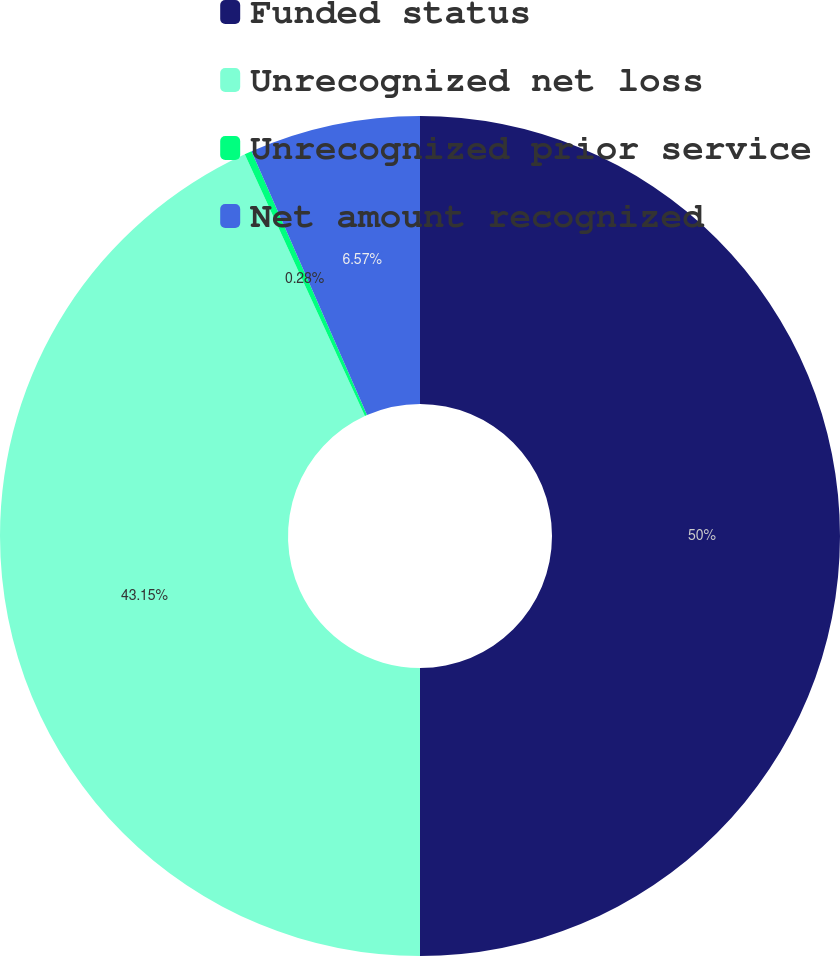Convert chart. <chart><loc_0><loc_0><loc_500><loc_500><pie_chart><fcel>Funded status<fcel>Unrecognized net loss<fcel>Unrecognized prior service<fcel>Net amount recognized<nl><fcel>50.0%<fcel>43.15%<fcel>0.28%<fcel>6.57%<nl></chart> 